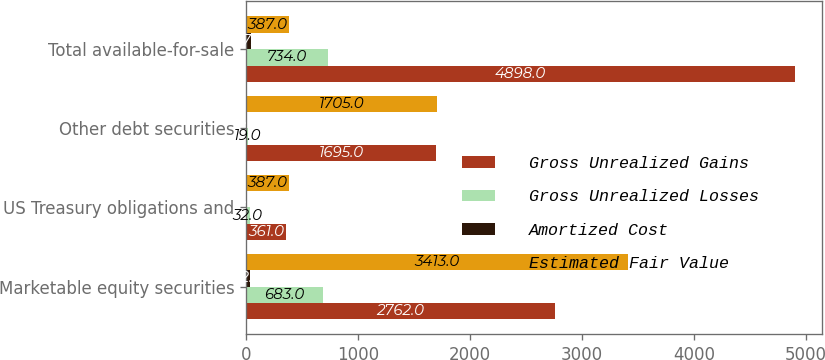Convert chart to OTSL. <chart><loc_0><loc_0><loc_500><loc_500><stacked_bar_chart><ecel><fcel>Marketable equity securities<fcel>US Treasury obligations and<fcel>Other debt securities<fcel>Total available-for-sale<nl><fcel>Gross Unrealized Gains<fcel>2762<fcel>361<fcel>1695<fcel>4898<nl><fcel>Gross Unrealized Losses<fcel>683<fcel>32<fcel>19<fcel>734<nl><fcel>Amortized Cost<fcel>32<fcel>6<fcel>9<fcel>47<nl><fcel>Estimated Fair Value<fcel>3413<fcel>387<fcel>1705<fcel>387<nl></chart> 